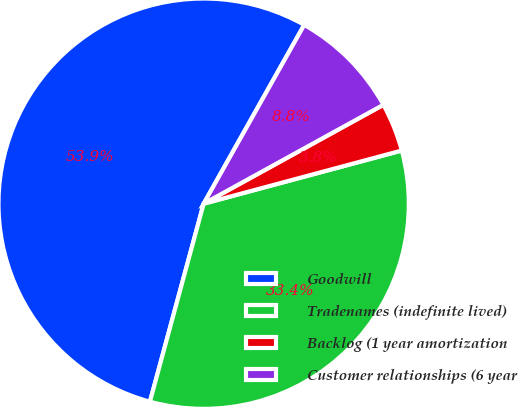Convert chart to OTSL. <chart><loc_0><loc_0><loc_500><loc_500><pie_chart><fcel>Goodwill<fcel>Tradenames (indefinite lived)<fcel>Backlog (1 year amortization<fcel>Customer relationships (6 year<nl><fcel>53.93%<fcel>33.39%<fcel>3.83%<fcel>8.84%<nl></chart> 